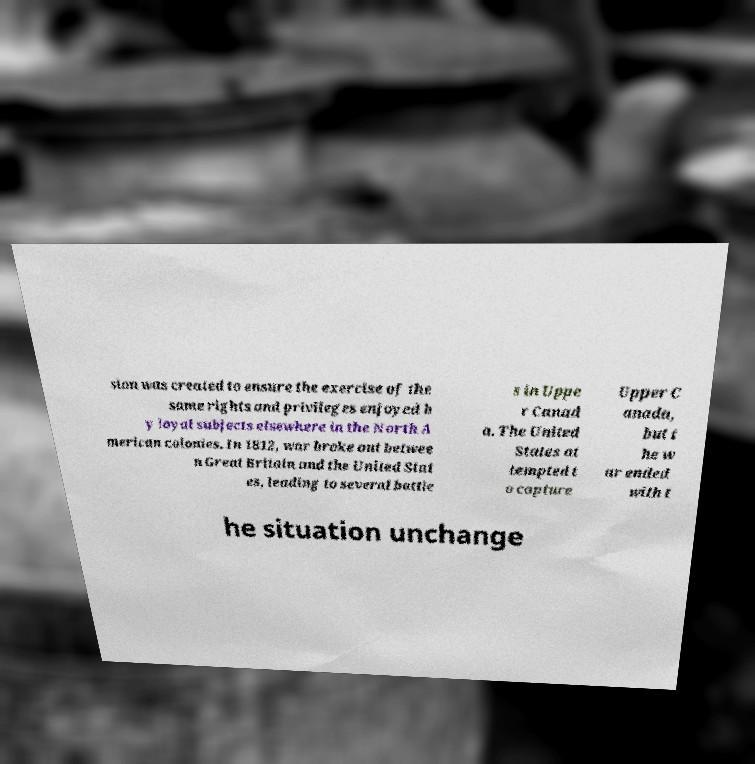Can you read and provide the text displayed in the image?This photo seems to have some interesting text. Can you extract and type it out for me? sion was created to ensure the exercise of the same rights and privileges enjoyed b y loyal subjects elsewhere in the North A merican colonies. In 1812, war broke out betwee n Great Britain and the United Stat es, leading to several battle s in Uppe r Canad a. The United States at tempted t o capture Upper C anada, but t he w ar ended with t he situation unchange 